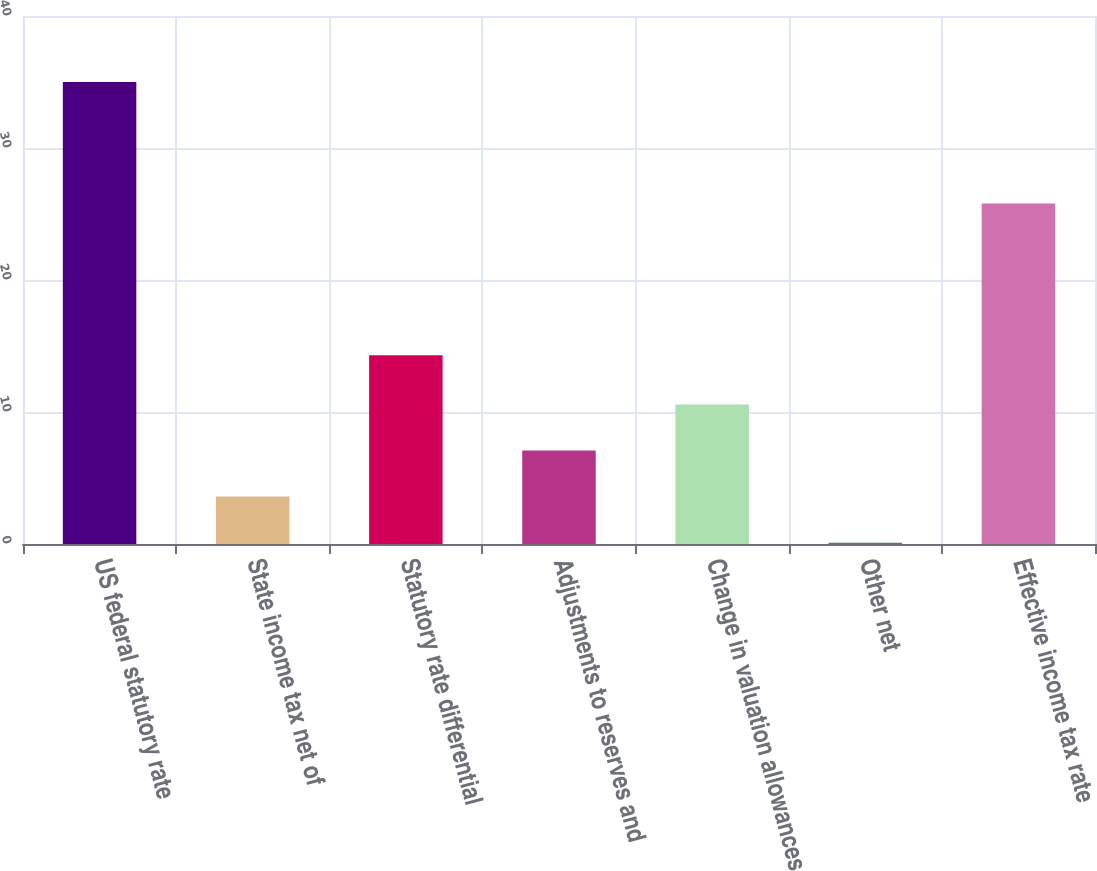<chart> <loc_0><loc_0><loc_500><loc_500><bar_chart><fcel>US federal statutory rate<fcel>State income tax net of<fcel>Statutory rate differential<fcel>Adjustments to reserves and<fcel>Change in valuation allowances<fcel>Other net<fcel>Effective income tax rate<nl><fcel>35<fcel>3.59<fcel>14.3<fcel>7.08<fcel>10.57<fcel>0.1<fcel>25.8<nl></chart> 